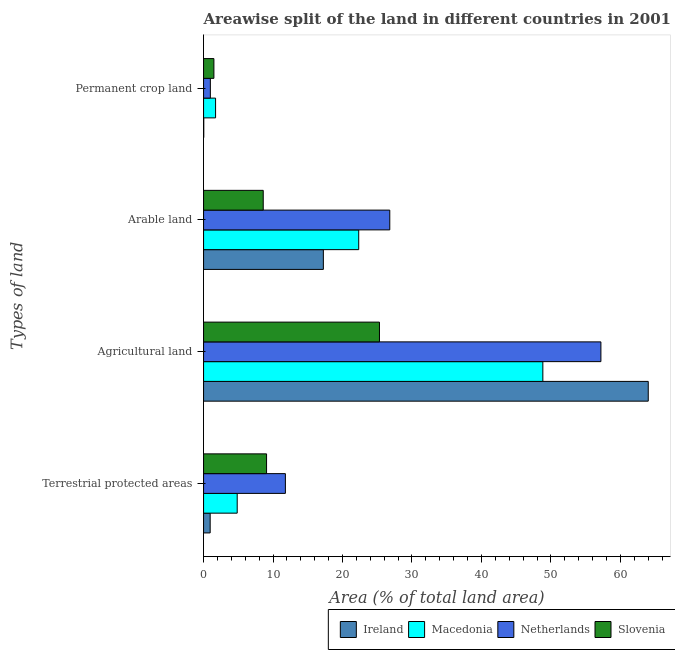How many different coloured bars are there?
Make the answer very short. 4. How many groups of bars are there?
Your response must be concise. 4. Are the number of bars per tick equal to the number of legend labels?
Give a very brief answer. Yes. How many bars are there on the 2nd tick from the bottom?
Provide a short and direct response. 4. What is the label of the 2nd group of bars from the top?
Your answer should be very brief. Arable land. What is the percentage of area under arable land in Macedonia?
Keep it short and to the point. 22.34. Across all countries, what is the maximum percentage of area under permanent crop land?
Provide a succinct answer. 1.73. Across all countries, what is the minimum percentage of area under arable land?
Offer a very short reply. 8.59. In which country was the percentage of area under permanent crop land maximum?
Your answer should be compact. Macedonia. In which country was the percentage of area under agricultural land minimum?
Keep it short and to the point. Slovenia. What is the total percentage of area under permanent crop land in the graph?
Provide a short and direct response. 4.23. What is the difference between the percentage of area under arable land in Slovenia and that in Netherlands?
Make the answer very short. -18.22. What is the difference between the percentage of area under agricultural land in Slovenia and the percentage of land under terrestrial protection in Netherlands?
Ensure brevity in your answer.  13.54. What is the average percentage of area under agricultural land per country?
Your response must be concise. 48.84. What is the difference between the percentage of land under terrestrial protection and percentage of area under agricultural land in Ireland?
Your answer should be very brief. -63.06. What is the ratio of the percentage of area under arable land in Ireland to that in Slovenia?
Offer a terse response. 2.01. Is the difference between the percentage of land under terrestrial protection in Slovenia and Macedonia greater than the difference between the percentage of area under arable land in Slovenia and Macedonia?
Offer a terse response. Yes. What is the difference between the highest and the second highest percentage of area under arable land?
Make the answer very short. 4.47. What is the difference between the highest and the lowest percentage of area under arable land?
Keep it short and to the point. 18.22. What does the 4th bar from the top in Agricultural land represents?
Provide a succinct answer. Ireland. What does the 2nd bar from the bottom in Permanent crop land represents?
Your response must be concise. Macedonia. Is it the case that in every country, the sum of the percentage of land under terrestrial protection and percentage of area under agricultural land is greater than the percentage of area under arable land?
Ensure brevity in your answer.  Yes. Are all the bars in the graph horizontal?
Offer a terse response. Yes. What is the difference between two consecutive major ticks on the X-axis?
Provide a succinct answer. 10. Where does the legend appear in the graph?
Provide a short and direct response. Bottom right. How many legend labels are there?
Your answer should be very brief. 4. What is the title of the graph?
Your answer should be very brief. Areawise split of the land in different countries in 2001. Does "Austria" appear as one of the legend labels in the graph?
Provide a short and direct response. No. What is the label or title of the X-axis?
Your answer should be compact. Area (% of total land area). What is the label or title of the Y-axis?
Your answer should be very brief. Types of land. What is the Area (% of total land area) in Ireland in Terrestrial protected areas?
Give a very brief answer. 0.95. What is the Area (% of total land area) of Macedonia in Terrestrial protected areas?
Provide a short and direct response. 4.84. What is the Area (% of total land area) in Netherlands in Terrestrial protected areas?
Your answer should be very brief. 11.78. What is the Area (% of total land area) of Slovenia in Terrestrial protected areas?
Ensure brevity in your answer.  9.07. What is the Area (% of total land area) of Ireland in Agricultural land?
Give a very brief answer. 64.02. What is the Area (% of total land area) of Macedonia in Agricultural land?
Offer a very short reply. 48.84. What is the Area (% of total land area) of Netherlands in Agricultural land?
Make the answer very short. 57.2. What is the Area (% of total land area) of Slovenia in Agricultural land?
Your answer should be compact. 25.32. What is the Area (% of total land area) of Ireland in Arable land?
Your answer should be compact. 17.24. What is the Area (% of total land area) in Macedonia in Arable land?
Make the answer very short. 22.34. What is the Area (% of total land area) of Netherlands in Arable land?
Provide a succinct answer. 26.81. What is the Area (% of total land area) in Slovenia in Arable land?
Your answer should be very brief. 8.59. What is the Area (% of total land area) in Ireland in Permanent crop land?
Offer a very short reply. 0.03. What is the Area (% of total land area) in Macedonia in Permanent crop land?
Your response must be concise. 1.73. What is the Area (% of total land area) of Netherlands in Permanent crop land?
Your answer should be compact. 0.98. What is the Area (% of total land area) in Slovenia in Permanent crop land?
Keep it short and to the point. 1.49. Across all Types of land, what is the maximum Area (% of total land area) of Ireland?
Offer a very short reply. 64.02. Across all Types of land, what is the maximum Area (% of total land area) of Macedonia?
Make the answer very short. 48.84. Across all Types of land, what is the maximum Area (% of total land area) of Netherlands?
Your response must be concise. 57.2. Across all Types of land, what is the maximum Area (% of total land area) of Slovenia?
Offer a terse response. 25.32. Across all Types of land, what is the minimum Area (% of total land area) in Ireland?
Your answer should be very brief. 0.03. Across all Types of land, what is the minimum Area (% of total land area) of Macedonia?
Your answer should be compact. 1.73. Across all Types of land, what is the minimum Area (% of total land area) of Netherlands?
Offer a terse response. 0.98. Across all Types of land, what is the minimum Area (% of total land area) in Slovenia?
Make the answer very short. 1.49. What is the total Area (% of total land area) in Ireland in the graph?
Provide a succinct answer. 82.24. What is the total Area (% of total land area) of Macedonia in the graph?
Your answer should be compact. 77.75. What is the total Area (% of total land area) in Netherlands in the graph?
Your answer should be very brief. 96.76. What is the total Area (% of total land area) of Slovenia in the graph?
Offer a very short reply. 44.47. What is the difference between the Area (% of total land area) in Ireland in Terrestrial protected areas and that in Agricultural land?
Your response must be concise. -63.06. What is the difference between the Area (% of total land area) in Macedonia in Terrestrial protected areas and that in Agricultural land?
Keep it short and to the point. -44. What is the difference between the Area (% of total land area) in Netherlands in Terrestrial protected areas and that in Agricultural land?
Your answer should be compact. -45.42. What is the difference between the Area (% of total land area) in Slovenia in Terrestrial protected areas and that in Agricultural land?
Provide a short and direct response. -16.25. What is the difference between the Area (% of total land area) of Ireland in Terrestrial protected areas and that in Arable land?
Keep it short and to the point. -16.29. What is the difference between the Area (% of total land area) in Macedonia in Terrestrial protected areas and that in Arable land?
Your response must be concise. -17.49. What is the difference between the Area (% of total land area) of Netherlands in Terrestrial protected areas and that in Arable land?
Your answer should be very brief. -15.03. What is the difference between the Area (% of total land area) in Slovenia in Terrestrial protected areas and that in Arable land?
Keep it short and to the point. 0.48. What is the difference between the Area (% of total land area) in Ireland in Terrestrial protected areas and that in Permanent crop land?
Ensure brevity in your answer.  0.92. What is the difference between the Area (% of total land area) of Macedonia in Terrestrial protected areas and that in Permanent crop land?
Provide a succinct answer. 3.11. What is the difference between the Area (% of total land area) of Netherlands in Terrestrial protected areas and that in Permanent crop land?
Offer a very short reply. 10.8. What is the difference between the Area (% of total land area) in Slovenia in Terrestrial protected areas and that in Permanent crop land?
Provide a short and direct response. 7.58. What is the difference between the Area (% of total land area) of Ireland in Agricultural land and that in Arable land?
Your response must be concise. 46.77. What is the difference between the Area (% of total land area) in Macedonia in Agricultural land and that in Arable land?
Your answer should be compact. 26.5. What is the difference between the Area (% of total land area) in Netherlands in Agricultural land and that in Arable land?
Provide a short and direct response. 30.39. What is the difference between the Area (% of total land area) of Slovenia in Agricultural land and that in Arable land?
Give a very brief answer. 16.73. What is the difference between the Area (% of total land area) of Ireland in Agricultural land and that in Permanent crop land?
Your answer should be compact. 63.99. What is the difference between the Area (% of total land area) in Macedonia in Agricultural land and that in Permanent crop land?
Make the answer very short. 47.11. What is the difference between the Area (% of total land area) of Netherlands in Agricultural land and that in Permanent crop land?
Provide a succinct answer. 56.22. What is the difference between the Area (% of total land area) of Slovenia in Agricultural land and that in Permanent crop land?
Provide a succinct answer. 23.83. What is the difference between the Area (% of total land area) in Ireland in Arable land and that in Permanent crop land?
Make the answer very short. 17.22. What is the difference between the Area (% of total land area) of Macedonia in Arable land and that in Permanent crop land?
Make the answer very short. 20.61. What is the difference between the Area (% of total land area) of Netherlands in Arable land and that in Permanent crop land?
Provide a succinct answer. 25.83. What is the difference between the Area (% of total land area) in Slovenia in Arable land and that in Permanent crop land?
Give a very brief answer. 7.1. What is the difference between the Area (% of total land area) in Ireland in Terrestrial protected areas and the Area (% of total land area) in Macedonia in Agricultural land?
Provide a succinct answer. -47.89. What is the difference between the Area (% of total land area) in Ireland in Terrestrial protected areas and the Area (% of total land area) in Netherlands in Agricultural land?
Ensure brevity in your answer.  -56.25. What is the difference between the Area (% of total land area) in Ireland in Terrestrial protected areas and the Area (% of total land area) in Slovenia in Agricultural land?
Offer a terse response. -24.37. What is the difference between the Area (% of total land area) in Macedonia in Terrestrial protected areas and the Area (% of total land area) in Netherlands in Agricultural land?
Provide a short and direct response. -52.36. What is the difference between the Area (% of total land area) in Macedonia in Terrestrial protected areas and the Area (% of total land area) in Slovenia in Agricultural land?
Ensure brevity in your answer.  -20.48. What is the difference between the Area (% of total land area) in Netherlands in Terrestrial protected areas and the Area (% of total land area) in Slovenia in Agricultural land?
Offer a terse response. -13.54. What is the difference between the Area (% of total land area) in Ireland in Terrestrial protected areas and the Area (% of total land area) in Macedonia in Arable land?
Your answer should be very brief. -21.38. What is the difference between the Area (% of total land area) in Ireland in Terrestrial protected areas and the Area (% of total land area) in Netherlands in Arable land?
Offer a very short reply. -25.86. What is the difference between the Area (% of total land area) of Ireland in Terrestrial protected areas and the Area (% of total land area) of Slovenia in Arable land?
Your answer should be compact. -7.64. What is the difference between the Area (% of total land area) of Macedonia in Terrestrial protected areas and the Area (% of total land area) of Netherlands in Arable land?
Provide a short and direct response. -21.96. What is the difference between the Area (% of total land area) of Macedonia in Terrestrial protected areas and the Area (% of total land area) of Slovenia in Arable land?
Keep it short and to the point. -3.75. What is the difference between the Area (% of total land area) in Netherlands in Terrestrial protected areas and the Area (% of total land area) in Slovenia in Arable land?
Provide a short and direct response. 3.19. What is the difference between the Area (% of total land area) of Ireland in Terrestrial protected areas and the Area (% of total land area) of Macedonia in Permanent crop land?
Offer a terse response. -0.78. What is the difference between the Area (% of total land area) in Ireland in Terrestrial protected areas and the Area (% of total land area) in Netherlands in Permanent crop land?
Provide a short and direct response. -0.03. What is the difference between the Area (% of total land area) of Ireland in Terrestrial protected areas and the Area (% of total land area) of Slovenia in Permanent crop land?
Give a very brief answer. -0.54. What is the difference between the Area (% of total land area) in Macedonia in Terrestrial protected areas and the Area (% of total land area) in Netherlands in Permanent crop land?
Make the answer very short. 3.86. What is the difference between the Area (% of total land area) in Macedonia in Terrestrial protected areas and the Area (% of total land area) in Slovenia in Permanent crop land?
Keep it short and to the point. 3.35. What is the difference between the Area (% of total land area) of Netherlands in Terrestrial protected areas and the Area (% of total land area) of Slovenia in Permanent crop land?
Give a very brief answer. 10.29. What is the difference between the Area (% of total land area) of Ireland in Agricultural land and the Area (% of total land area) of Macedonia in Arable land?
Ensure brevity in your answer.  41.68. What is the difference between the Area (% of total land area) in Ireland in Agricultural land and the Area (% of total land area) in Netherlands in Arable land?
Your answer should be compact. 37.21. What is the difference between the Area (% of total land area) of Ireland in Agricultural land and the Area (% of total land area) of Slovenia in Arable land?
Make the answer very short. 55.43. What is the difference between the Area (% of total land area) in Macedonia in Agricultural land and the Area (% of total land area) in Netherlands in Arable land?
Your answer should be compact. 22.03. What is the difference between the Area (% of total land area) in Macedonia in Agricultural land and the Area (% of total land area) in Slovenia in Arable land?
Your answer should be compact. 40.25. What is the difference between the Area (% of total land area) of Netherlands in Agricultural land and the Area (% of total land area) of Slovenia in Arable land?
Provide a short and direct response. 48.61. What is the difference between the Area (% of total land area) in Ireland in Agricultural land and the Area (% of total land area) in Macedonia in Permanent crop land?
Provide a succinct answer. 62.28. What is the difference between the Area (% of total land area) of Ireland in Agricultural land and the Area (% of total land area) of Netherlands in Permanent crop land?
Give a very brief answer. 63.04. What is the difference between the Area (% of total land area) in Ireland in Agricultural land and the Area (% of total land area) in Slovenia in Permanent crop land?
Ensure brevity in your answer.  62.53. What is the difference between the Area (% of total land area) in Macedonia in Agricultural land and the Area (% of total land area) in Netherlands in Permanent crop land?
Provide a succinct answer. 47.86. What is the difference between the Area (% of total land area) of Macedonia in Agricultural land and the Area (% of total land area) of Slovenia in Permanent crop land?
Keep it short and to the point. 47.35. What is the difference between the Area (% of total land area) in Netherlands in Agricultural land and the Area (% of total land area) in Slovenia in Permanent crop land?
Offer a very short reply. 55.71. What is the difference between the Area (% of total land area) of Ireland in Arable land and the Area (% of total land area) of Macedonia in Permanent crop land?
Make the answer very short. 15.51. What is the difference between the Area (% of total land area) of Ireland in Arable land and the Area (% of total land area) of Netherlands in Permanent crop land?
Keep it short and to the point. 16.27. What is the difference between the Area (% of total land area) in Ireland in Arable land and the Area (% of total land area) in Slovenia in Permanent crop land?
Keep it short and to the point. 15.76. What is the difference between the Area (% of total land area) in Macedonia in Arable land and the Area (% of total land area) in Netherlands in Permanent crop land?
Offer a terse response. 21.36. What is the difference between the Area (% of total land area) of Macedonia in Arable land and the Area (% of total land area) of Slovenia in Permanent crop land?
Your response must be concise. 20.85. What is the difference between the Area (% of total land area) in Netherlands in Arable land and the Area (% of total land area) in Slovenia in Permanent crop land?
Offer a very short reply. 25.32. What is the average Area (% of total land area) of Ireland per Types of land?
Give a very brief answer. 20.56. What is the average Area (% of total land area) of Macedonia per Types of land?
Your answer should be compact. 19.44. What is the average Area (% of total land area) of Netherlands per Types of land?
Your response must be concise. 24.19. What is the average Area (% of total land area) in Slovenia per Types of land?
Offer a very short reply. 11.12. What is the difference between the Area (% of total land area) in Ireland and Area (% of total land area) in Macedonia in Terrestrial protected areas?
Give a very brief answer. -3.89. What is the difference between the Area (% of total land area) in Ireland and Area (% of total land area) in Netherlands in Terrestrial protected areas?
Your response must be concise. -10.83. What is the difference between the Area (% of total land area) in Ireland and Area (% of total land area) in Slovenia in Terrestrial protected areas?
Your answer should be very brief. -8.12. What is the difference between the Area (% of total land area) of Macedonia and Area (% of total land area) of Netherlands in Terrestrial protected areas?
Your answer should be compact. -6.94. What is the difference between the Area (% of total land area) of Macedonia and Area (% of total land area) of Slovenia in Terrestrial protected areas?
Ensure brevity in your answer.  -4.23. What is the difference between the Area (% of total land area) in Netherlands and Area (% of total land area) in Slovenia in Terrestrial protected areas?
Your answer should be compact. 2.71. What is the difference between the Area (% of total land area) of Ireland and Area (% of total land area) of Macedonia in Agricultural land?
Offer a very short reply. 15.18. What is the difference between the Area (% of total land area) in Ireland and Area (% of total land area) in Netherlands in Agricultural land?
Provide a succinct answer. 6.82. What is the difference between the Area (% of total land area) in Ireland and Area (% of total land area) in Slovenia in Agricultural land?
Offer a very short reply. 38.69. What is the difference between the Area (% of total land area) of Macedonia and Area (% of total land area) of Netherlands in Agricultural land?
Your answer should be very brief. -8.36. What is the difference between the Area (% of total land area) of Macedonia and Area (% of total land area) of Slovenia in Agricultural land?
Give a very brief answer. 23.52. What is the difference between the Area (% of total land area) in Netherlands and Area (% of total land area) in Slovenia in Agricultural land?
Make the answer very short. 31.88. What is the difference between the Area (% of total land area) of Ireland and Area (% of total land area) of Macedonia in Arable land?
Your answer should be very brief. -5.09. What is the difference between the Area (% of total land area) of Ireland and Area (% of total land area) of Netherlands in Arable land?
Ensure brevity in your answer.  -9.56. What is the difference between the Area (% of total land area) of Ireland and Area (% of total land area) of Slovenia in Arable land?
Offer a very short reply. 8.65. What is the difference between the Area (% of total land area) in Macedonia and Area (% of total land area) in Netherlands in Arable land?
Keep it short and to the point. -4.47. What is the difference between the Area (% of total land area) of Macedonia and Area (% of total land area) of Slovenia in Arable land?
Make the answer very short. 13.75. What is the difference between the Area (% of total land area) in Netherlands and Area (% of total land area) in Slovenia in Arable land?
Provide a short and direct response. 18.22. What is the difference between the Area (% of total land area) in Ireland and Area (% of total land area) in Macedonia in Permanent crop land?
Keep it short and to the point. -1.7. What is the difference between the Area (% of total land area) in Ireland and Area (% of total land area) in Netherlands in Permanent crop land?
Offer a very short reply. -0.95. What is the difference between the Area (% of total land area) of Ireland and Area (% of total land area) of Slovenia in Permanent crop land?
Give a very brief answer. -1.46. What is the difference between the Area (% of total land area) in Macedonia and Area (% of total land area) in Netherlands in Permanent crop land?
Make the answer very short. 0.75. What is the difference between the Area (% of total land area) in Macedonia and Area (% of total land area) in Slovenia in Permanent crop land?
Give a very brief answer. 0.24. What is the difference between the Area (% of total land area) in Netherlands and Area (% of total land area) in Slovenia in Permanent crop land?
Offer a very short reply. -0.51. What is the ratio of the Area (% of total land area) in Ireland in Terrestrial protected areas to that in Agricultural land?
Provide a succinct answer. 0.01. What is the ratio of the Area (% of total land area) of Macedonia in Terrestrial protected areas to that in Agricultural land?
Your answer should be very brief. 0.1. What is the ratio of the Area (% of total land area) of Netherlands in Terrestrial protected areas to that in Agricultural land?
Provide a short and direct response. 0.21. What is the ratio of the Area (% of total land area) of Slovenia in Terrestrial protected areas to that in Agricultural land?
Your answer should be very brief. 0.36. What is the ratio of the Area (% of total land area) in Ireland in Terrestrial protected areas to that in Arable land?
Provide a succinct answer. 0.06. What is the ratio of the Area (% of total land area) in Macedonia in Terrestrial protected areas to that in Arable land?
Ensure brevity in your answer.  0.22. What is the ratio of the Area (% of total land area) of Netherlands in Terrestrial protected areas to that in Arable land?
Keep it short and to the point. 0.44. What is the ratio of the Area (% of total land area) of Slovenia in Terrestrial protected areas to that in Arable land?
Make the answer very short. 1.06. What is the ratio of the Area (% of total land area) of Ireland in Terrestrial protected areas to that in Permanent crop land?
Your answer should be very brief. 32.78. What is the ratio of the Area (% of total land area) in Macedonia in Terrestrial protected areas to that in Permanent crop land?
Keep it short and to the point. 2.8. What is the ratio of the Area (% of total land area) in Netherlands in Terrestrial protected areas to that in Permanent crop land?
Provide a succinct answer. 12.05. What is the ratio of the Area (% of total land area) of Slovenia in Terrestrial protected areas to that in Permanent crop land?
Your response must be concise. 6.09. What is the ratio of the Area (% of total land area) in Ireland in Agricultural land to that in Arable land?
Provide a short and direct response. 3.71. What is the ratio of the Area (% of total land area) in Macedonia in Agricultural land to that in Arable land?
Provide a short and direct response. 2.19. What is the ratio of the Area (% of total land area) of Netherlands in Agricultural land to that in Arable land?
Offer a very short reply. 2.13. What is the ratio of the Area (% of total land area) of Slovenia in Agricultural land to that in Arable land?
Your response must be concise. 2.95. What is the ratio of the Area (% of total land area) of Ireland in Agricultural land to that in Permanent crop land?
Provide a short and direct response. 2205. What is the ratio of the Area (% of total land area) of Macedonia in Agricultural land to that in Permanent crop land?
Offer a terse response. 28.23. What is the ratio of the Area (% of total land area) in Netherlands in Agricultural land to that in Permanent crop land?
Your answer should be compact. 58.52. What is the ratio of the Area (% of total land area) in Ireland in Arable land to that in Permanent crop land?
Make the answer very short. 594. What is the ratio of the Area (% of total land area) of Macedonia in Arable land to that in Permanent crop land?
Keep it short and to the point. 12.91. What is the ratio of the Area (% of total land area) in Netherlands in Arable land to that in Permanent crop land?
Keep it short and to the point. 27.42. What is the ratio of the Area (% of total land area) in Slovenia in Arable land to that in Permanent crop land?
Offer a terse response. 5.77. What is the difference between the highest and the second highest Area (% of total land area) of Ireland?
Ensure brevity in your answer.  46.77. What is the difference between the highest and the second highest Area (% of total land area) of Macedonia?
Provide a succinct answer. 26.5. What is the difference between the highest and the second highest Area (% of total land area) in Netherlands?
Ensure brevity in your answer.  30.39. What is the difference between the highest and the second highest Area (% of total land area) in Slovenia?
Ensure brevity in your answer.  16.25. What is the difference between the highest and the lowest Area (% of total land area) in Ireland?
Ensure brevity in your answer.  63.99. What is the difference between the highest and the lowest Area (% of total land area) of Macedonia?
Ensure brevity in your answer.  47.11. What is the difference between the highest and the lowest Area (% of total land area) of Netherlands?
Provide a short and direct response. 56.22. What is the difference between the highest and the lowest Area (% of total land area) in Slovenia?
Offer a terse response. 23.83. 